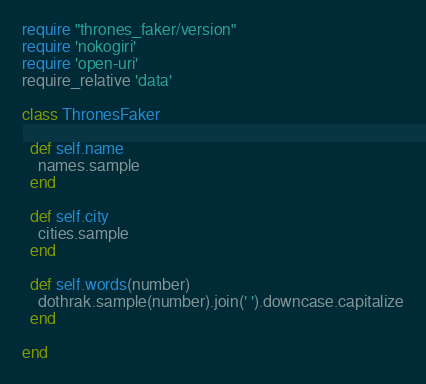<code> <loc_0><loc_0><loc_500><loc_500><_Ruby_>require "thrones_faker/version"
require 'nokogiri'
require 'open-uri'
require_relative 'data'

class ThronesFaker

  def self.name
    names.sample
  end

  def self.city
    cities.sample
  end

  def self.words(number)
    dothrak.sample(number).join(' ').downcase.capitalize
  end

end
</code> 